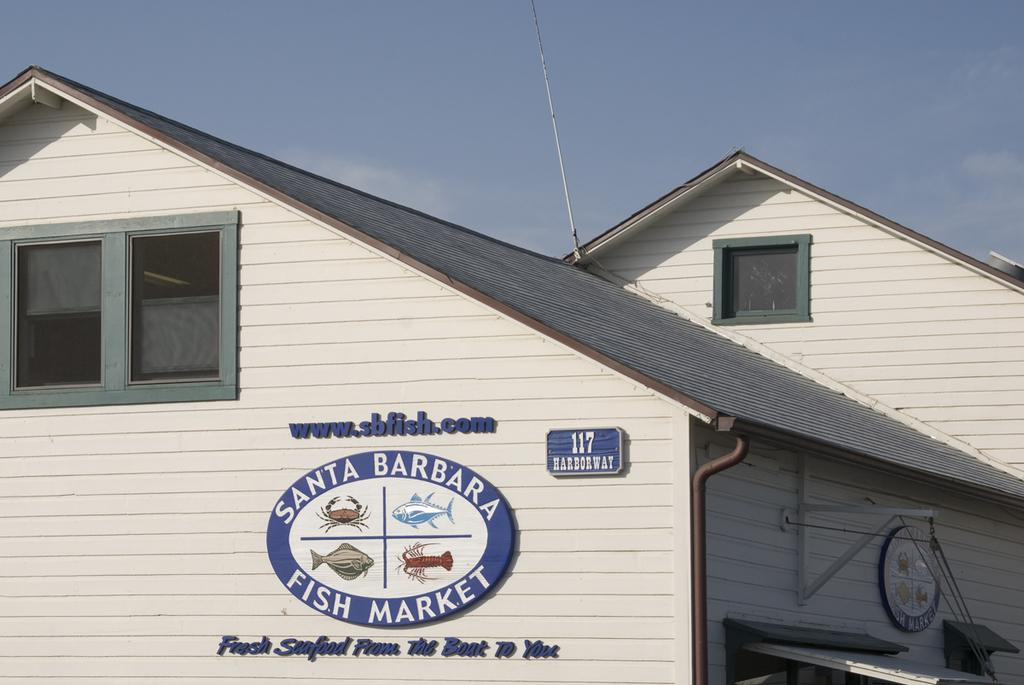What is the main subject in the center of the image? There is a building in the center of the image. What can be seen in the background of the image? There is a sky visible in the background of the image. What type of sticks are used to create the scarecrow in the image? There is no scarecrow present in the image, so there are no sticks used for it. What sound can be heard during the thunderstorm in the image? There is no thunderstorm present in the image, so no thunder sound can be heard. 